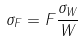<formula> <loc_0><loc_0><loc_500><loc_500>\sigma _ { F } = F \frac { \sigma _ { W } } { W }</formula> 